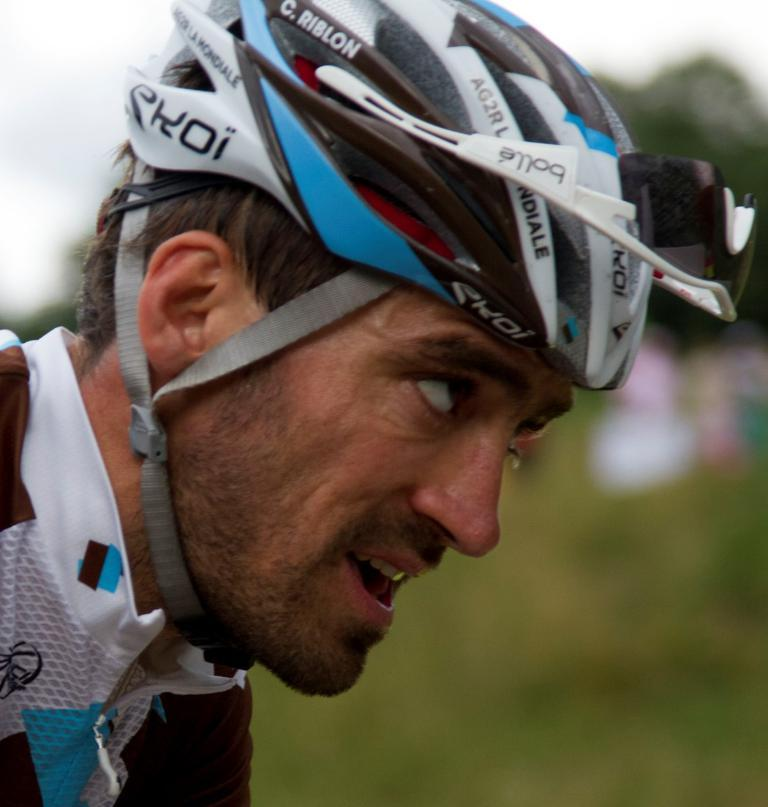What is the main subject of the image? There is a person in the image. What is the person wearing? The person is wearing a helmet. What can be seen in the background of the image? There are trees in the background of the image. How would you describe the background in the image? The background appears blurry. How much honey is being used by the person in the image? There is no honey present in the image, so it cannot be determined how much is being used. 